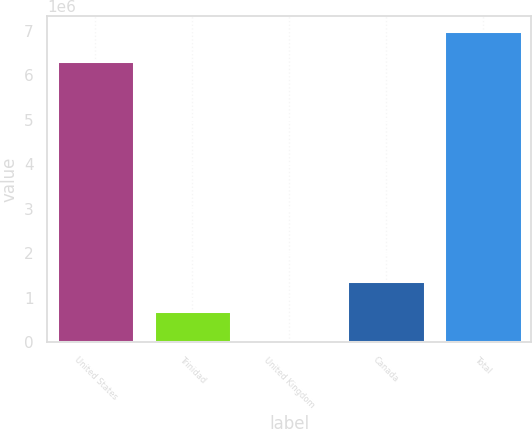<chart> <loc_0><loc_0><loc_500><loc_500><bar_chart><fcel>United States<fcel>Trinidad<fcel>United Kingdom<fcel>Canada<fcel>Total<nl><fcel>6.31843e+06<fcel>696567<fcel>24513<fcel>1.36862e+06<fcel>6.99048e+06<nl></chart> 